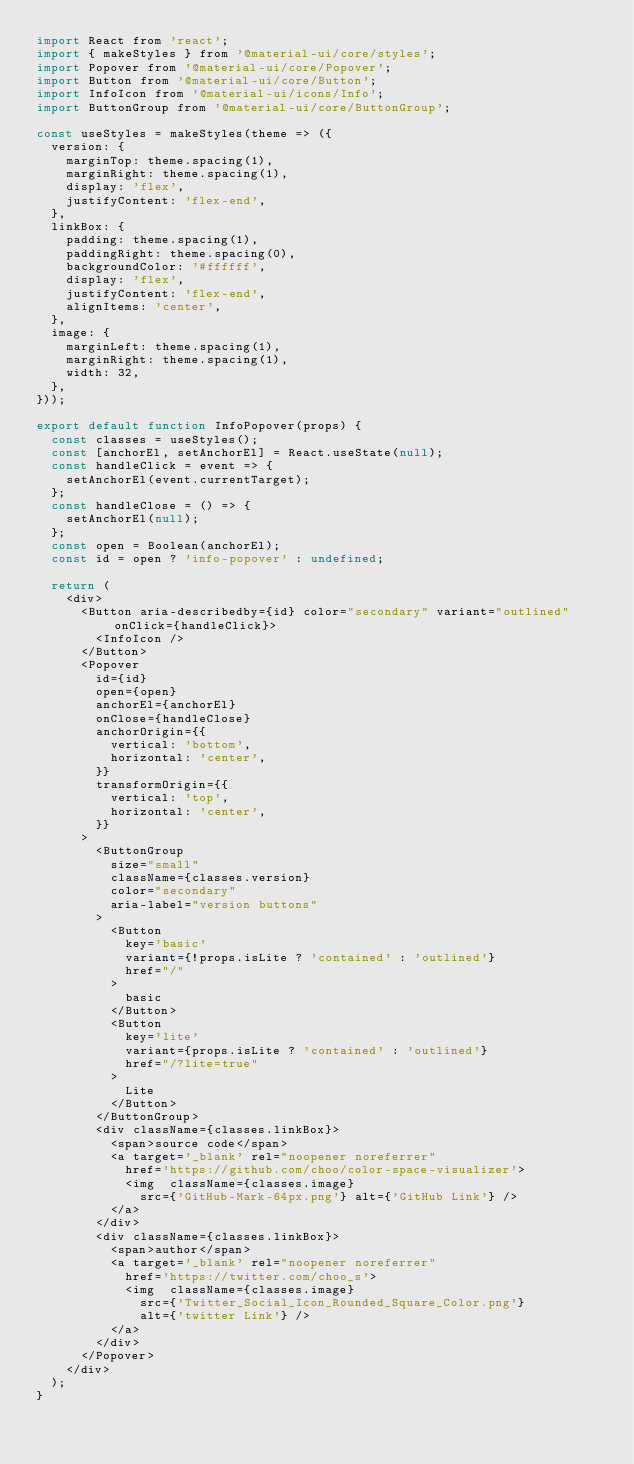Convert code to text. <code><loc_0><loc_0><loc_500><loc_500><_JavaScript_>import React from 'react';
import { makeStyles } from '@material-ui/core/styles';
import Popover from '@material-ui/core/Popover';
import Button from '@material-ui/core/Button';
import InfoIcon from '@material-ui/icons/Info';
import ButtonGroup from '@material-ui/core/ButtonGroup';

const useStyles = makeStyles(theme => ({
  version: {
    marginTop: theme.spacing(1),
    marginRight: theme.spacing(1),
    display: 'flex',
    justifyContent: 'flex-end',
  },
  linkBox: {
    padding: theme.spacing(1),
    paddingRight: theme.spacing(0),
    backgroundColor: '#ffffff',
    display: 'flex',
    justifyContent: 'flex-end',
    alignItems: 'center',
  },
  image: {
    marginLeft: theme.spacing(1),
    marginRight: theme.spacing(1),
    width: 32,
  },
}));

export default function InfoPopover(props) {
  const classes = useStyles();
  const [anchorEl, setAnchorEl] = React.useState(null);
  const handleClick = event => {
    setAnchorEl(event.currentTarget);
  };
  const handleClose = () => {
    setAnchorEl(null);
  };
  const open = Boolean(anchorEl);
  const id = open ? 'info-popover' : undefined;

  return (
    <div>
      <Button aria-describedby={id} color="secondary" variant="outlined" onClick={handleClick}>
        <InfoIcon />
      </Button>
      <Popover
        id={id}
        open={open}
        anchorEl={anchorEl}
        onClose={handleClose}
        anchorOrigin={{
          vertical: 'bottom',
          horizontal: 'center',
        }}
        transformOrigin={{
          vertical: 'top',
          horizontal: 'center',
        }}
      >
        <ButtonGroup
          size="small"
          className={classes.version}
          color="secondary"
          aria-label="version buttons"
        >
          <Button
            key='basic'
            variant={!props.isLite ? 'contained' : 'outlined'}
            href="/"
          >
            basic
          </Button>
          <Button
            key='lite'
            variant={props.isLite ? 'contained' : 'outlined'}
            href="/?lite=true"
          >
            Lite
          </Button>
        </ButtonGroup>
        <div className={classes.linkBox}>
          <span>source code</span>
          <a target='_blank' rel="noopener noreferrer"
            href='https://github.com/choo/color-space-visualizer'>
            <img  className={classes.image}
              src={'GitHub-Mark-64px.png'} alt={'GitHub Link'} />
          </a>
        </div>
        <div className={classes.linkBox}>
          <span>author</span>
          <a target='_blank' rel="noopener noreferrer"
            href='https://twitter.com/choo_s'>
            <img  className={classes.image}
              src={'Twitter_Social_Icon_Rounded_Square_Color.png'}
              alt={'twitter Link'} />
          </a>
        </div>
      </Popover>
    </div>
  );
}
</code> 